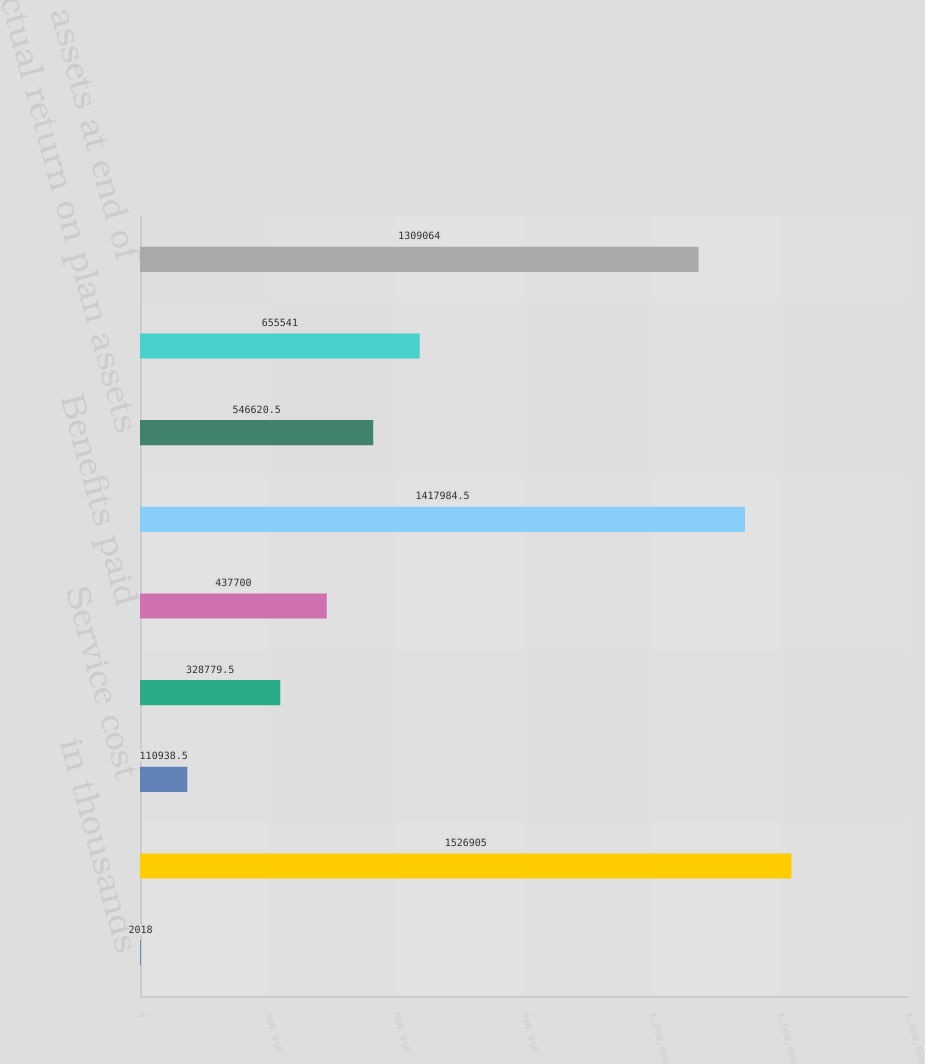<chart> <loc_0><loc_0><loc_500><loc_500><bar_chart><fcel>in thousands<fcel>Projected benefit obligation<fcel>Service cost<fcel>Interest cost<fcel>Benefits paid<fcel>Fair value of assets at<fcel>Actual return on plan assets<fcel>Employer contribution<fcel>Fair value of assets at end of<nl><fcel>2018<fcel>1.5269e+06<fcel>110938<fcel>328780<fcel>437700<fcel>1.41798e+06<fcel>546620<fcel>655541<fcel>1.30906e+06<nl></chart> 